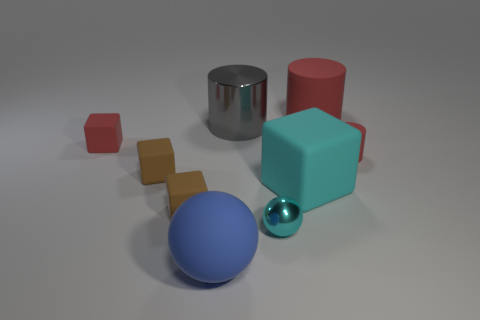Can you describe the various objects and their materials shown in this image? Certainly! In the image, we see a collection of geometrically shaped objects. We have a shiny metallic sphere, next to which there is a much smaller, similarly shiny metallic ball, which could be stainless steel or chrome-plated. There's also a matte red cylinder that might be made of plastic or painted wood, along with a large turquoise cube, which appears to be matte as well and could also be made of wood or plastic. Furthermore, there's a collection of smaller blocks in brown and red that look like they could be wooden. 